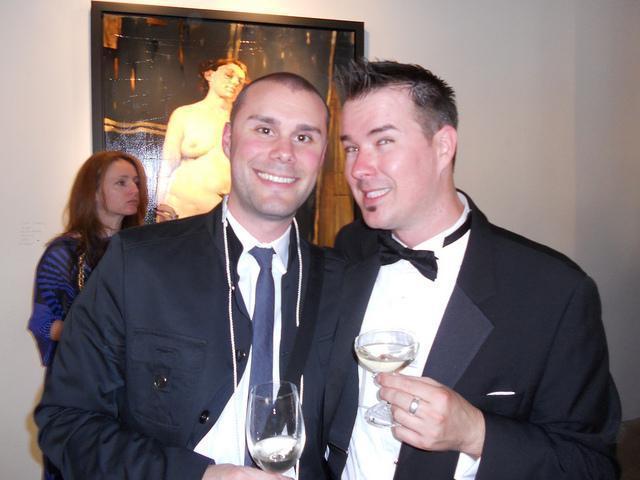From what fruit comes the item being drunk here?
Choose the right answer and clarify with the format: 'Answer: answer
Rationale: rationale.'
Options: Bananas, cherries, grapes, apples. Answer: grapes.
Rationale: The fruit is grapes. 